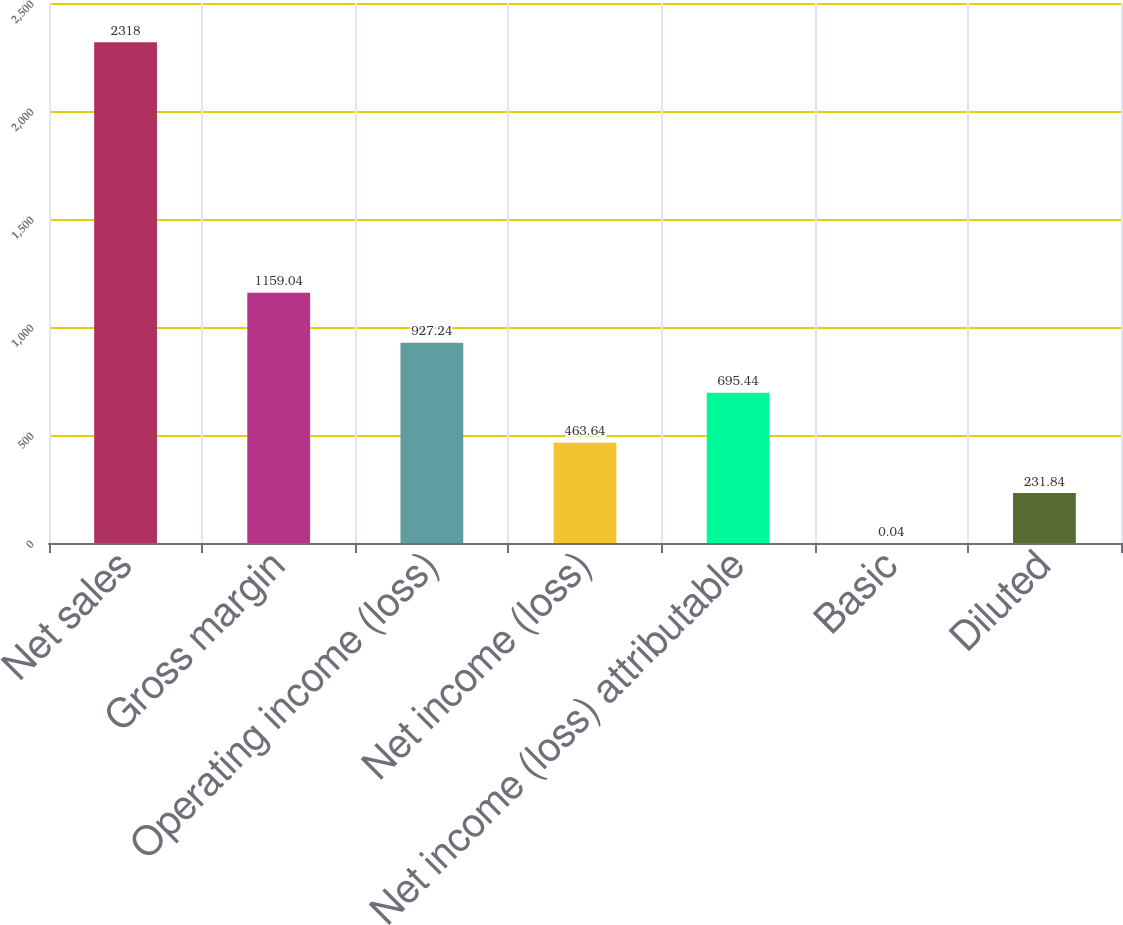Convert chart. <chart><loc_0><loc_0><loc_500><loc_500><bar_chart><fcel>Net sales<fcel>Gross margin<fcel>Operating income (loss)<fcel>Net income (loss)<fcel>Net income (loss) attributable<fcel>Basic<fcel>Diluted<nl><fcel>2318<fcel>1159.04<fcel>927.24<fcel>463.64<fcel>695.44<fcel>0.04<fcel>231.84<nl></chart> 